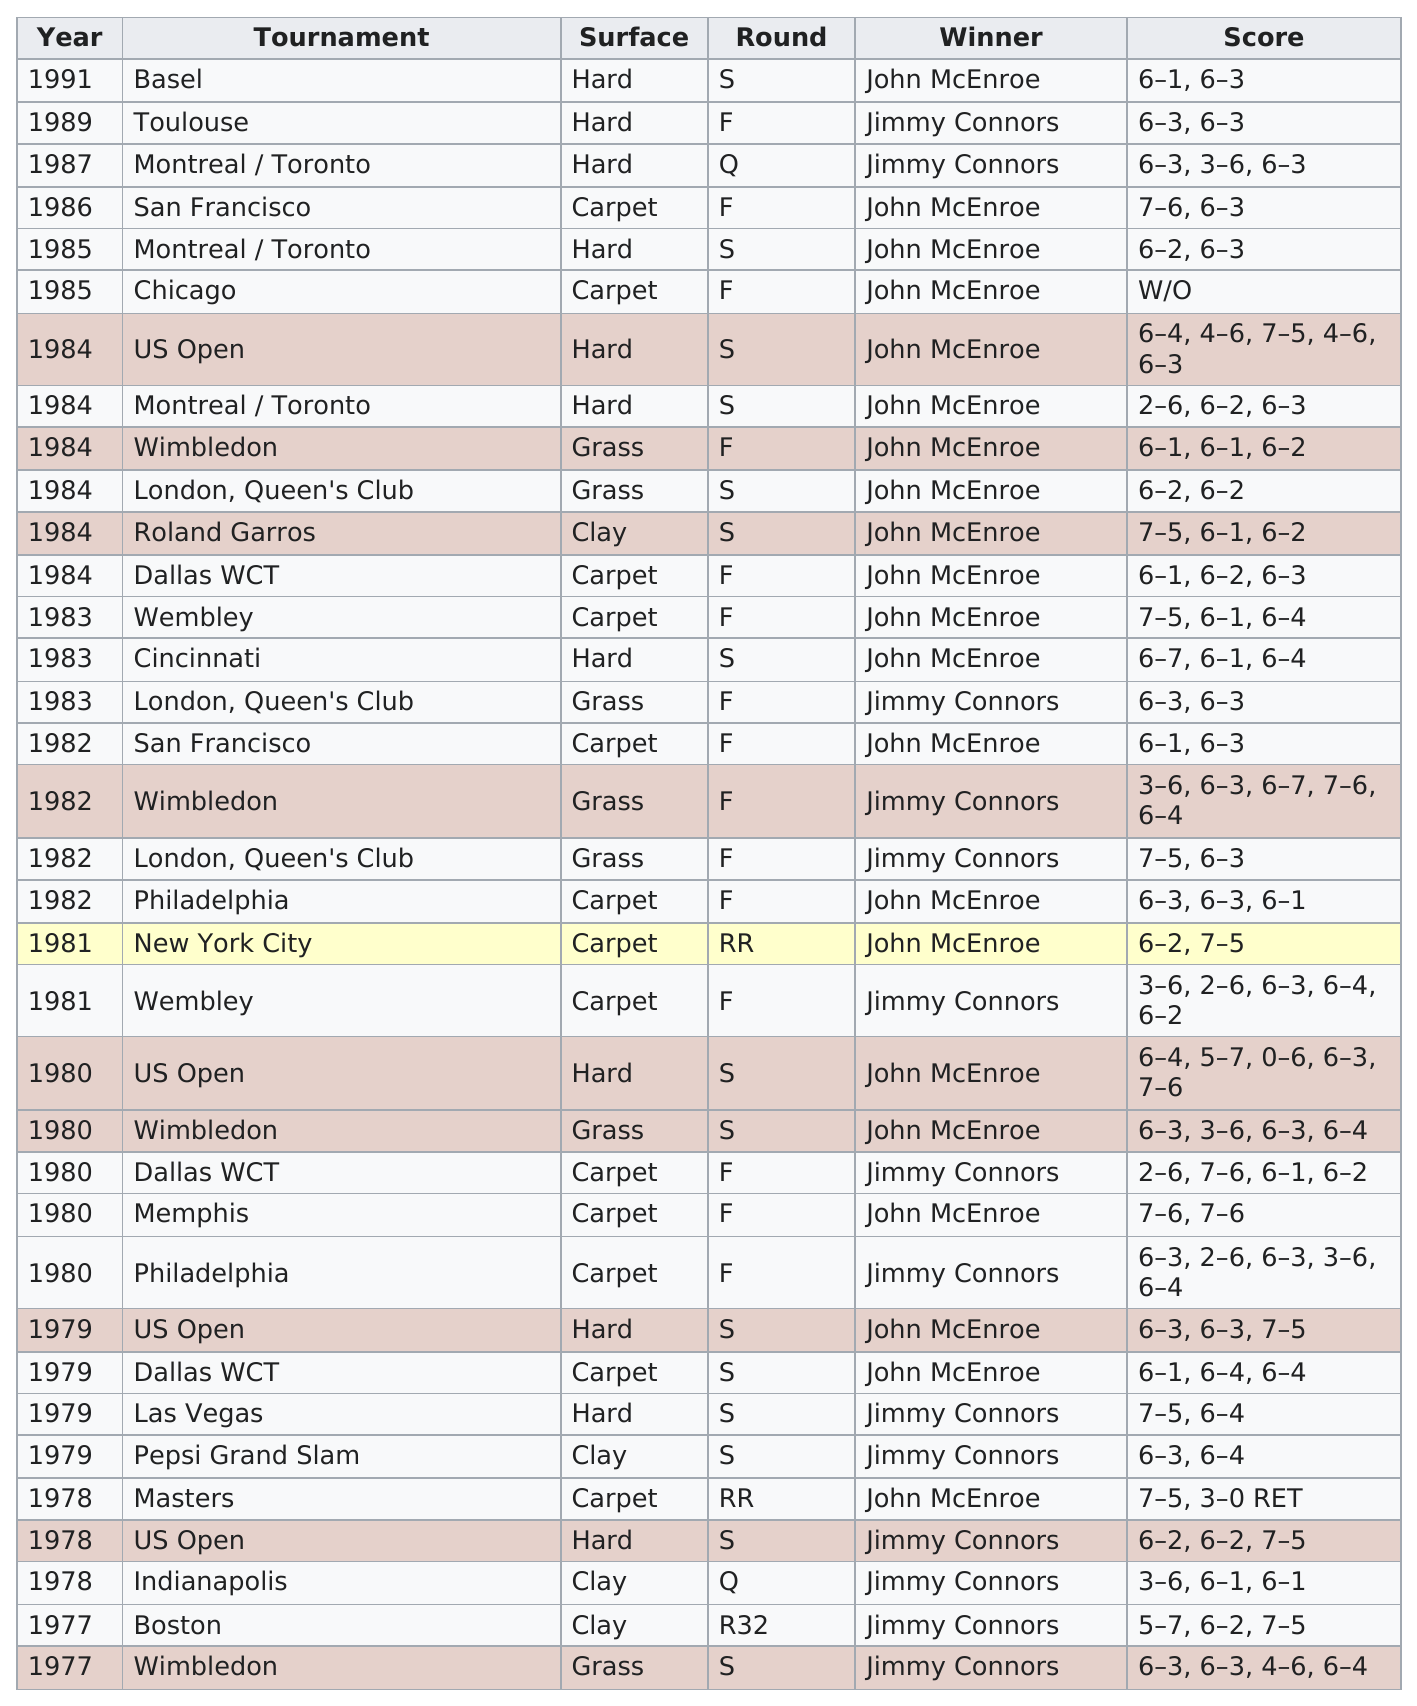Identify some key points in this picture. The total number of carpet surfaces used is 13. John McEnroe won 11 consecutive matches between 1987 and 1983. The men's lacrosse tournament was held in New York City before it was held in Philadelphia in 1982. John McEnroe is the person who won the most. John McEnroe won the US Open 11 times in the 1980s consecutively, making him the most successful player in the tournament's history. 